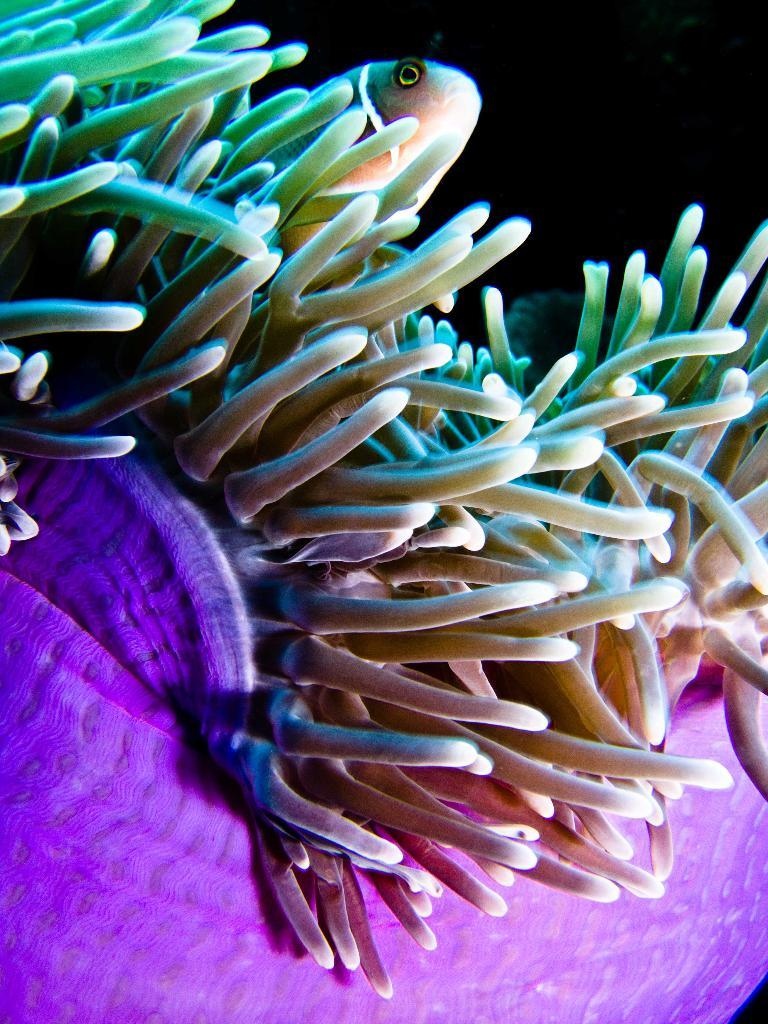What type of plants are visible in the image? There are water plants in the image. Can you describe any other living organisms in the image? Yes, there is a fish at the top of the image. What type of screw can be seen holding the grape in the image? There is no screw or grape present in the image. 